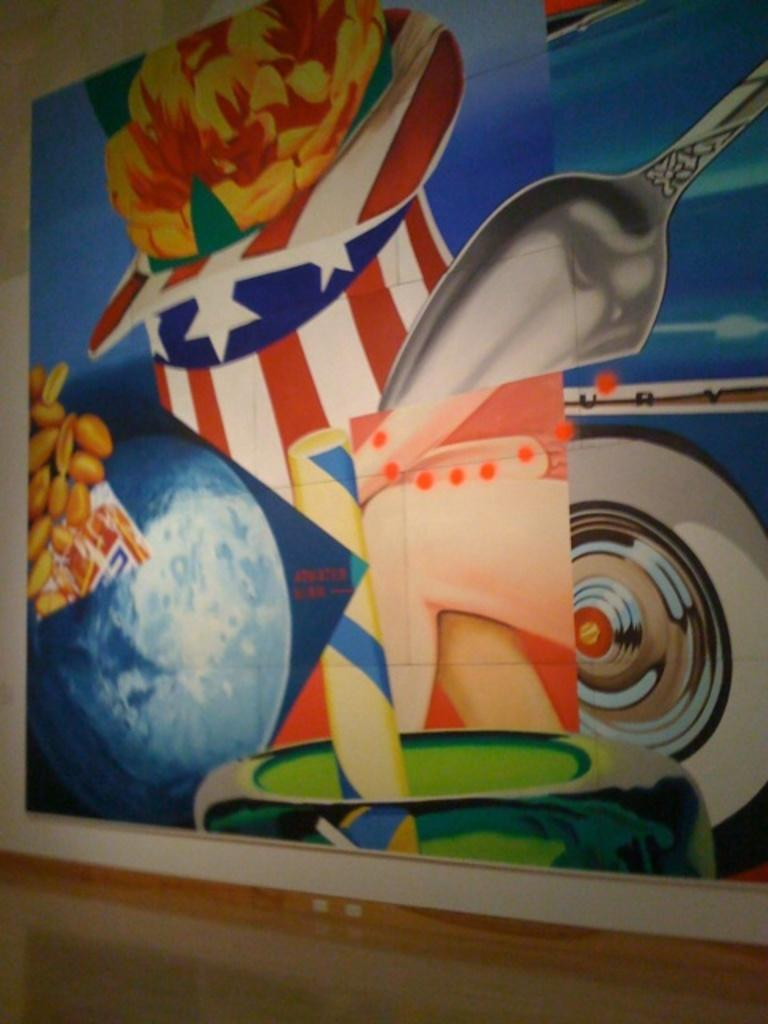What is displayed on the board in the image? There are paintings on a board in the image. Where is the board located? The board is on a wall. What can be seen at the bottom of the image? The floor is visible at the bottom of the image. How many chairs are visible in the image? There are no chairs visible in the image. Can you describe the texture of the paintings in the image? The provided facts do not include information about the texture of the paintings, so it cannot be described. 